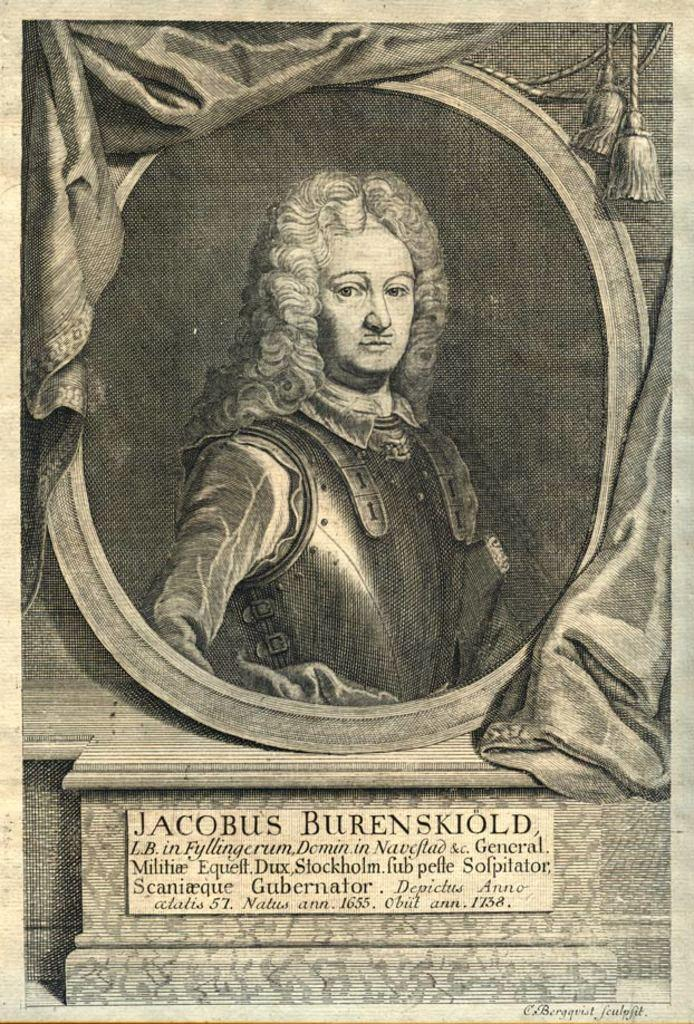What is the main subject of the poster in the image? The poster contains a black and white painting of a person. What is located under the painting on the poster? There is a board with notes under the painting. Can you see a robin in the image? There is no robin present in the image. What type of soup is being served in the image? There is no soup present in the image. 